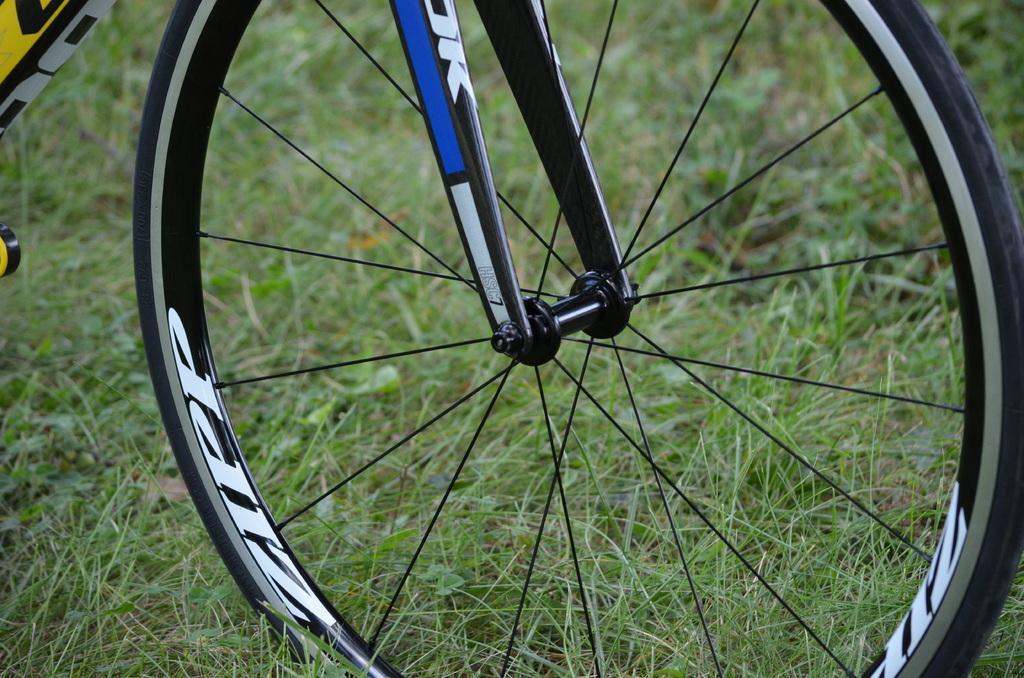Can you describe this image briefly? In this picture we can see a bicycle on the ground and in the background we can see grass. 